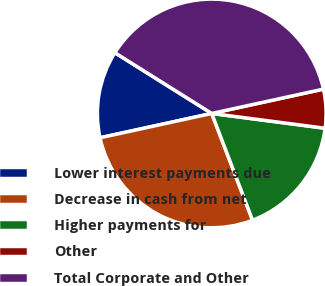Convert chart to OTSL. <chart><loc_0><loc_0><loc_500><loc_500><pie_chart><fcel>Lower interest payments due<fcel>Decrease in cash from net<fcel>Higher payments for<fcel>Other<fcel>Total Corporate and Other<nl><fcel>12.33%<fcel>27.4%<fcel>17.12%<fcel>5.48%<fcel>37.67%<nl></chart> 